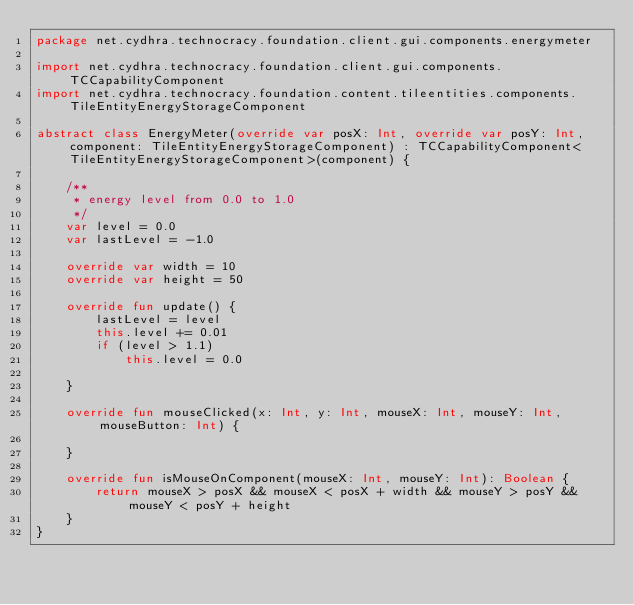<code> <loc_0><loc_0><loc_500><loc_500><_Kotlin_>package net.cydhra.technocracy.foundation.client.gui.components.energymeter

import net.cydhra.technocracy.foundation.client.gui.components.TCCapabilityComponent
import net.cydhra.technocracy.foundation.content.tileentities.components.TileEntityEnergyStorageComponent

abstract class EnergyMeter(override var posX: Int, override var posY: Int, component: TileEntityEnergyStorageComponent) : TCCapabilityComponent<TileEntityEnergyStorageComponent>(component) {

    /**
     * energy level from 0.0 to 1.0
     */
    var level = 0.0
    var lastLevel = -1.0

    override var width = 10
    override var height = 50

    override fun update() {
        lastLevel = level
        this.level += 0.01
        if (level > 1.1)
            this.level = 0.0

    }

    override fun mouseClicked(x: Int, y: Int, mouseX: Int, mouseY: Int, mouseButton: Int) {

    }

    override fun isMouseOnComponent(mouseX: Int, mouseY: Int): Boolean {
        return mouseX > posX && mouseX < posX + width && mouseY > posY && mouseY < posY + height
    }
}</code> 